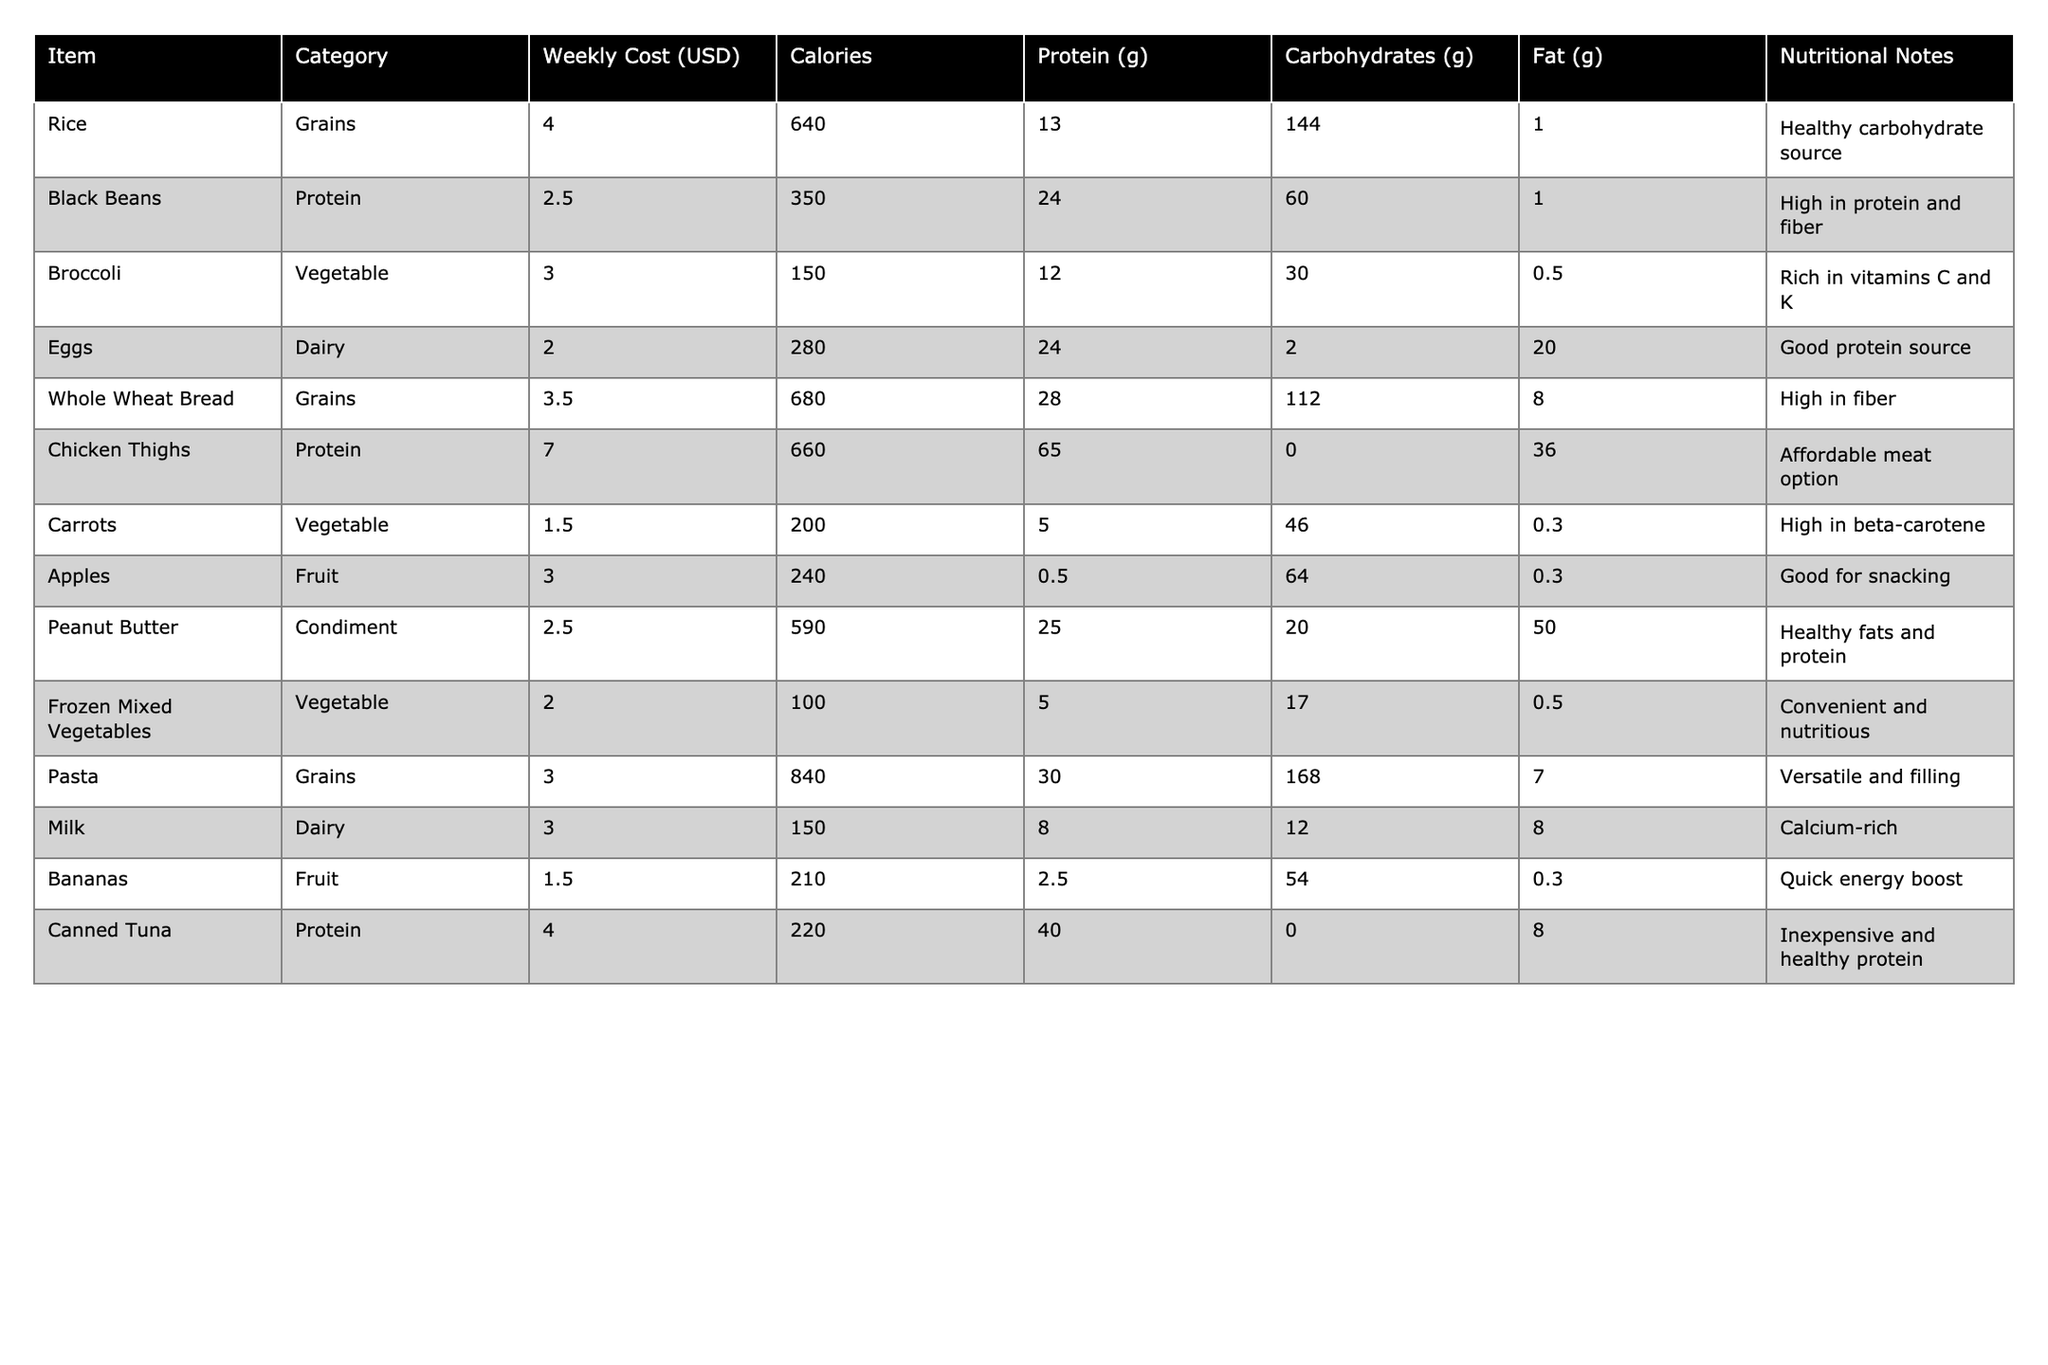What is the weekly cost of Black Beans? The table shows that Black Beans have a listed weekly cost of $2.50.
Answer: $2.50 Which item has the highest calorie content? The nutritional values indicate that Pasta has the highest calorie content at 840 calories.
Answer: Pasta What is the total weekly cost of all items? Adding the weekly costs: 4.00 + 2.50 + 3.00 + 2.00 + 3.50 + 7.00 + 1.50 + 3.00 + 2.50 + 2.00 + 3.00 + 1.50 + 4.00 = $34.00.
Answer: $34.00 Is Frozen Mixed Vegetables a healthy carbohydrate source? The table notes Frozen Mixed Vegetables as convenient and nutritious but does not classify it specifically as a carbohydrate source; therefore, it cannot be confirmed as such.
Answer: No What is the average protein content of all items? To calculate the average, sum the protein values: 13 + 24 + 12 + 24 + 28 + 65 + 5 + 0.5 + 25 + 5 + 8 + 2.5 + 40 =  9.7g, then divide by the total number of items (13):  238/13 ≈ 18.31g.
Answer: Approximately 18.31g Which category does Chicken Thighs belong to? The table categorizes Chicken Thighs under Protein.
Answer: Protein Are Carrots higher in calories than Apples? Carrots have 200 calories, while Apples have 240 calories; therefore, Carrots are not higher in calories than Apples.
Answer: No What is the total fat content for Rice and Pasta combined? The fat content for Rice (1.0g) plus Pasta (7.0g) equals 1.0 + 7.0 = 8.0g.
Answer: 8.0g How many grams of carbohydrates are in Peanut Butter? The table specifies that Peanut Butter contains 20 grams of carbohydrates.
Answer: 20g What nutritional note is provided for Eggs? The table states that Eggs are a good protein source.
Answer: Good protein source Which item has the lowest weekly cost and what is that cost? The item with the lowest cost is Carrots at $1.50.
Answer: $1.50 